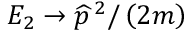<formula> <loc_0><loc_0><loc_500><loc_500>E _ { 2 } \rightarrow \widehat { p } ^ { \, 2 } / \left ( 2 m \right )</formula> 